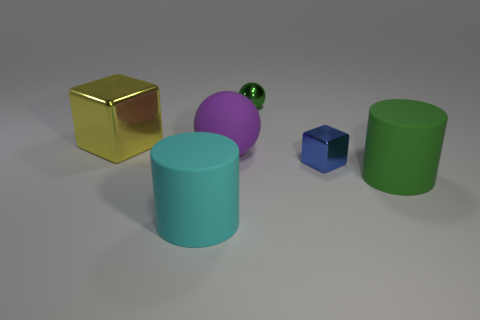Add 4 yellow cubes. How many objects exist? 10 Subtract all cubes. How many objects are left? 4 Subtract all purple cubes. Subtract all blue spheres. How many cubes are left? 2 Subtract all small shiny things. Subtract all blue shiny balls. How many objects are left? 4 Add 5 large cyan things. How many large cyan things are left? 6 Add 2 large yellow cylinders. How many large yellow cylinders exist? 2 Subtract 0 green blocks. How many objects are left? 6 Subtract 1 cylinders. How many cylinders are left? 1 